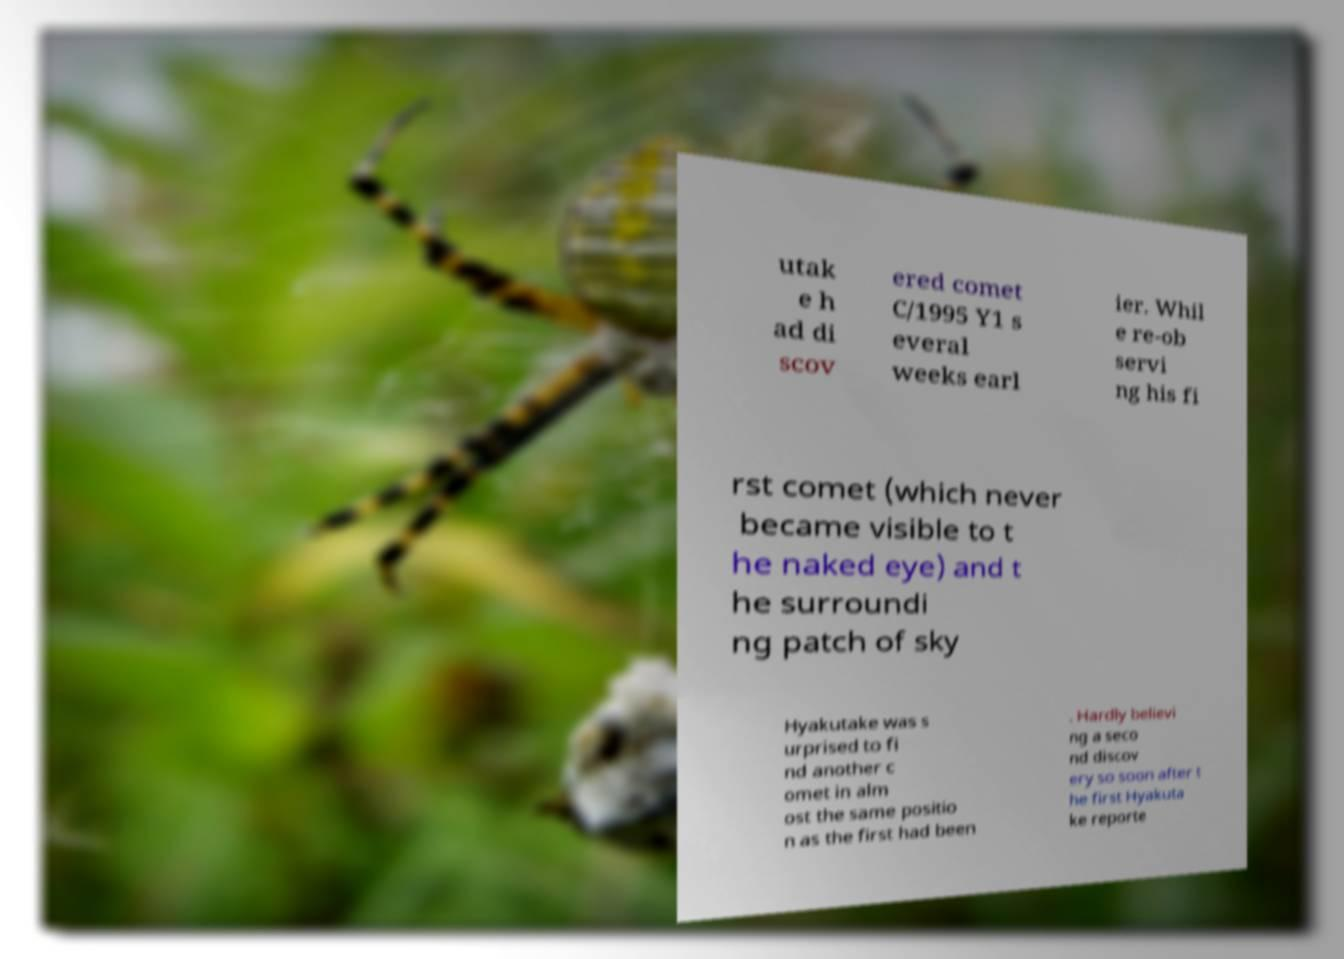There's text embedded in this image that I need extracted. Can you transcribe it verbatim? utak e h ad di scov ered comet C/1995 Y1 s everal weeks earl ier. Whil e re-ob servi ng his fi rst comet (which never became visible to t he naked eye) and t he surroundi ng patch of sky Hyakutake was s urprised to fi nd another c omet in alm ost the same positio n as the first had been . Hardly believi ng a seco nd discov ery so soon after t he first Hyakuta ke reporte 